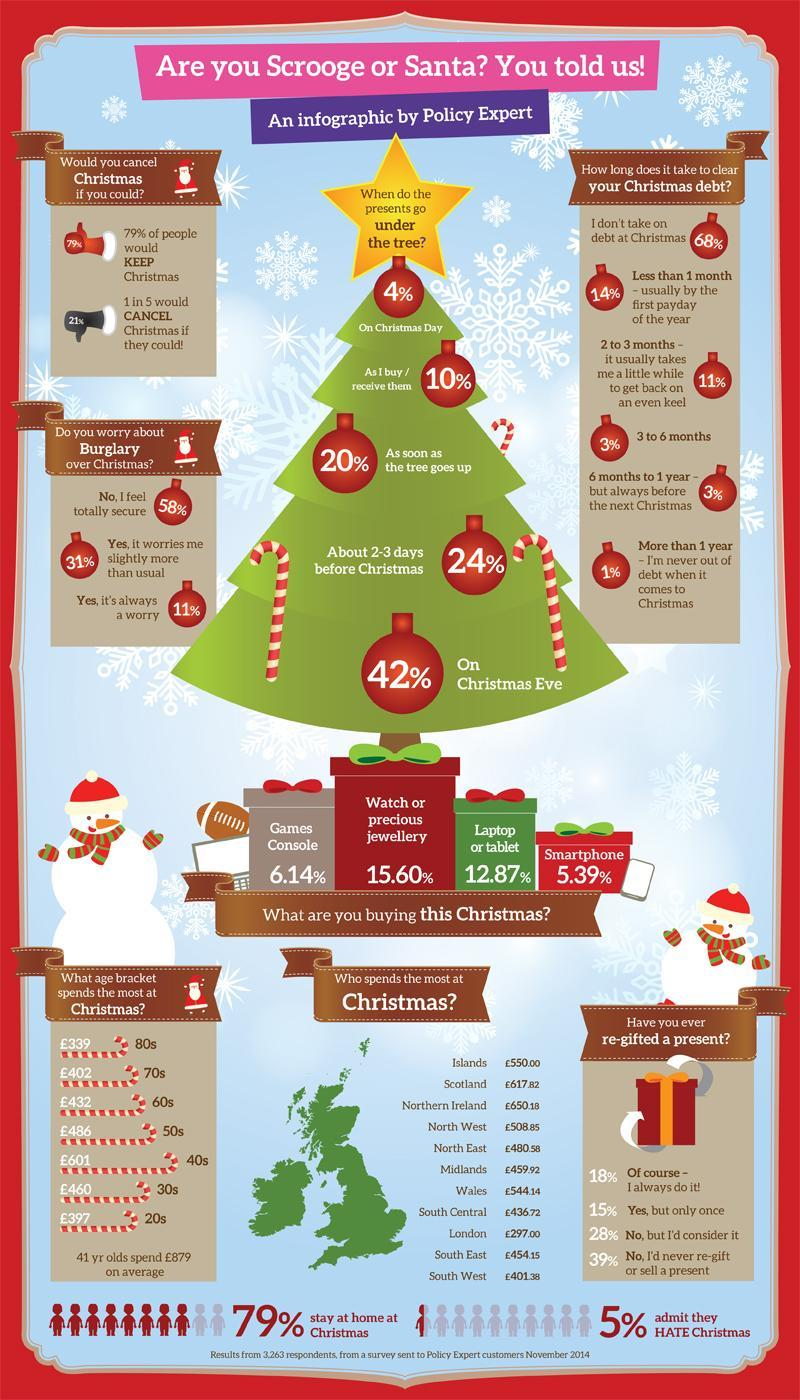Which area spends the second least at Christmas?
Answer the question with a short phrase. South West How many people do not worry about burglary over Christmas? 58% What percent of people buy Smartphone, Laptop or Tablet for Christmas? 18.26% Which area spends the third least at Christmas? South Central What age bracket spends the second most at Christmas? 50s What percentage of people have re-gifted a present at least once? 33% How many presents go under the tree on Christmas eve? 42% What percentage of people do not stay at home for Christmas? 21% What percentage of people take more than 3 months to clear Christmas debt? 7% Which area spends the most at Christmas? Northern Ireland Which area spends the third most at Christmas? Islands What percentage of people take debts at Christmas? 32% What percentage of people take more than 6 months to clear Christmas debt? 4% What age bracket spends the least at Christmas? 80s What percentage will consider re-gifting a present for Christmas? 28% How many people worry slightly or always about burglary over Christmas? 42% Which area spends the second most at Christmas? Scotland What percentage of people will cancel Christmas if they could? 21% 